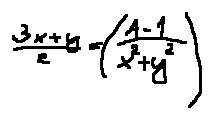<formula> <loc_0><loc_0><loc_500><loc_500>\frac { 3 x + y } { z } = ( \frac { A - 1 } { x ^ { 2 } + y ^ { 2 } } )</formula> 